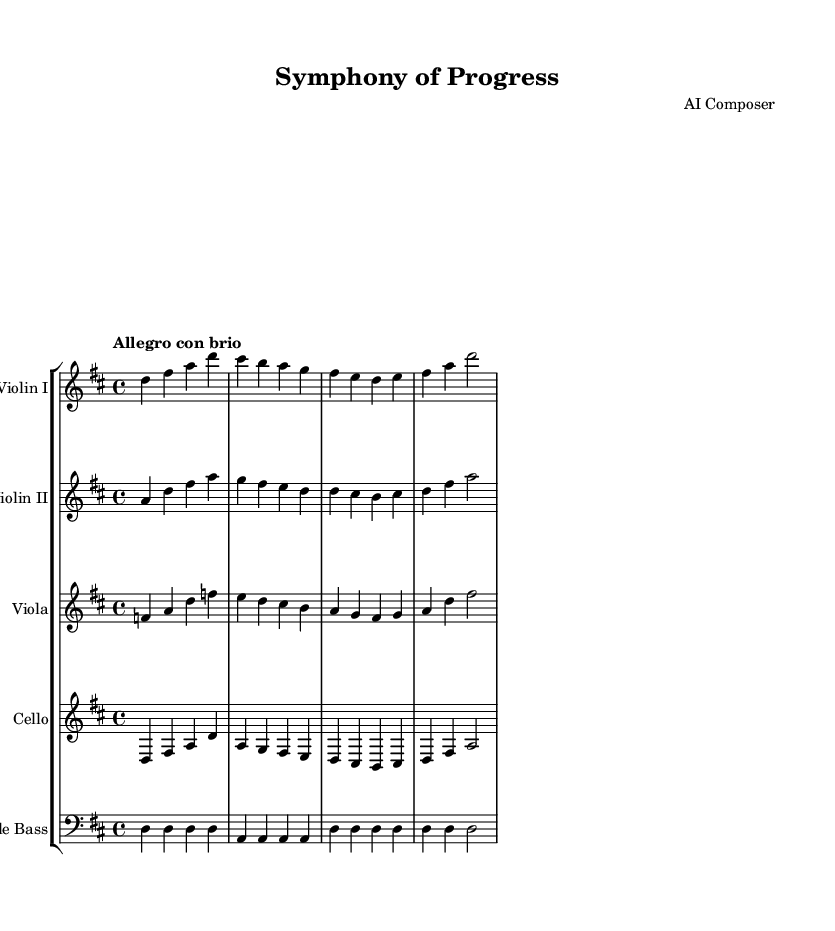What is the key signature of this music? The key signature is determined by looking at the key signature notation at the beginning of the staff. In this case, there are two sharps, which indicates that the piece is in D major.
Answer: D major What is the time signature of this music? The time signature can be found at the beginning of the music and shows the rhythm organization of the piece. Here, it is labeled as "4/4", which means there are four beats in each measure.
Answer: 4/4 What is the tempo marking of this music? The tempo marking is located above the staff and indicates the speed of the piece. Here, it specifies "Allegro con brio", which refers to a fast tempo with energy.
Answer: Allegro con brio Which instruments are featured in this symphony? The instruments are listed at the beginning of the score, where it shows different staves for each instrument. The instruments mentioned are Violin I, Violin II, Viola, Cello, and Double Bass.
Answer: Violin I, Violin II, Viola, Cello, Double Bass How many measures are there in the violin parts? To find the number of measures, you can count the measures represented in each violin staff, noting that each measure is separated by a vertical line. For both Violin I and Violin II, there are four measures in total.
Answer: 4 What is the melodic theme in the first measure of the first violin? The first measure of the first violin contains notes that can be analyzed to determine the theme. Observing the notes d, fis, a, and d indicates the beginning of a melodic phrase that sets a confident and uplifting tone.
Answer: d fis a d Which instrument plays the lowest pitch in this symphony? The pitch of different instruments can be evaluated by looking at their clefs and the notes they play. The double bass is generally tuned lower than the cello, and it is indeed the lowest instrument in this arrangement.
Answer: Double Bass 